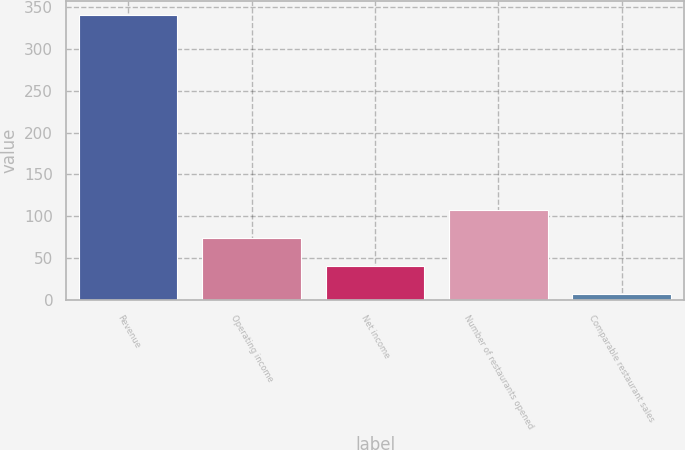Convert chart to OTSL. <chart><loc_0><loc_0><loc_500><loc_500><bar_chart><fcel>Revenue<fcel>Operating income<fcel>Net income<fcel>Number of restaurants opened<fcel>Comparable restaurant sales<nl><fcel>340.8<fcel>73.84<fcel>40.47<fcel>107.21<fcel>7.1<nl></chart> 